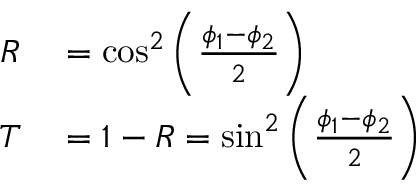<formula> <loc_0><loc_0><loc_500><loc_500>\begin{array} { r l } { R } & = \cos ^ { 2 } \left ( \frac { \phi _ { 1 } - \phi _ { 2 } } { 2 } \right ) } \\ { T } & = 1 - R = \sin ^ { 2 } \left ( \frac { \phi _ { 1 } - \phi _ { 2 } } { 2 } \right ) } \end{array}</formula> 